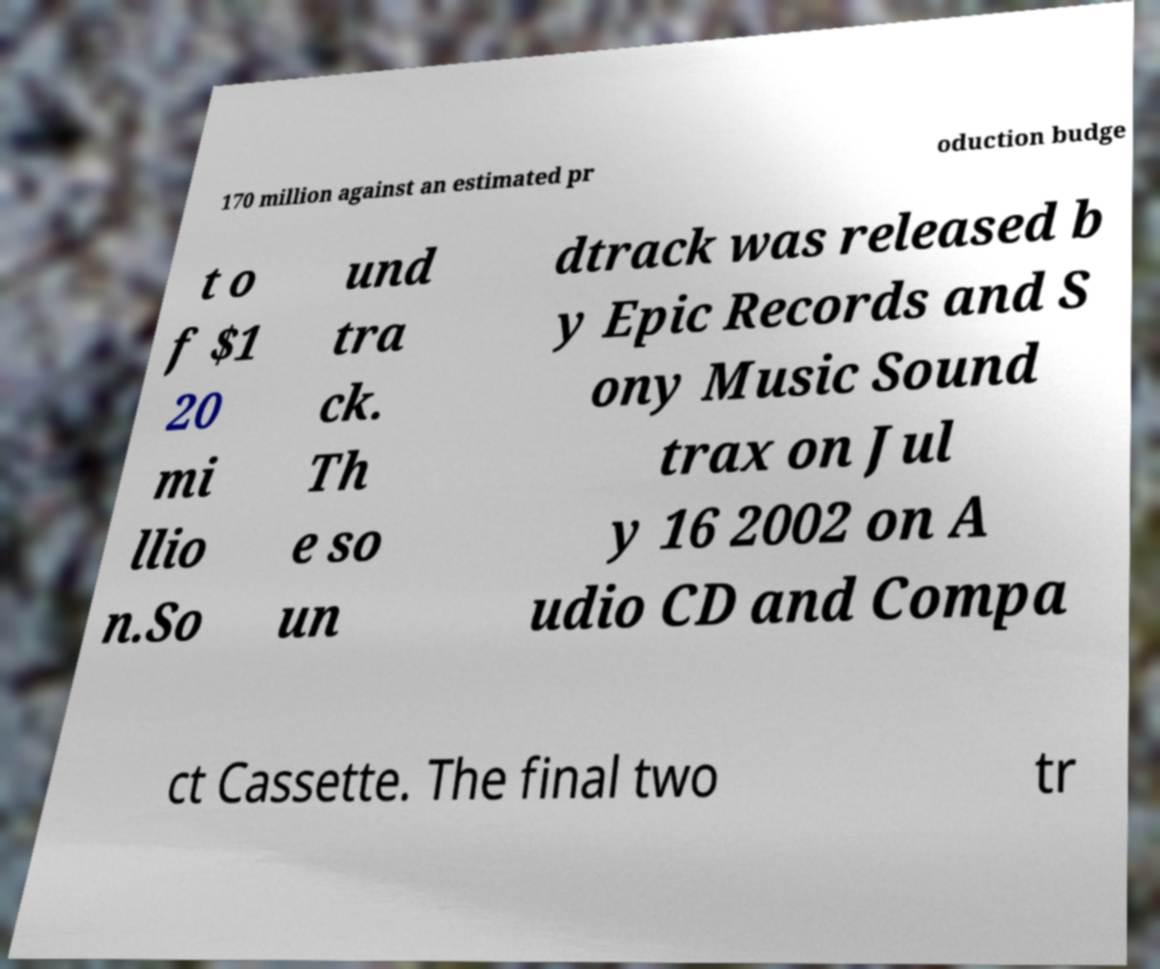There's text embedded in this image that I need extracted. Can you transcribe it verbatim? 170 million against an estimated pr oduction budge t o f $1 20 mi llio n.So und tra ck. Th e so un dtrack was released b y Epic Records and S ony Music Sound trax on Jul y 16 2002 on A udio CD and Compa ct Cassette. The final two tr 